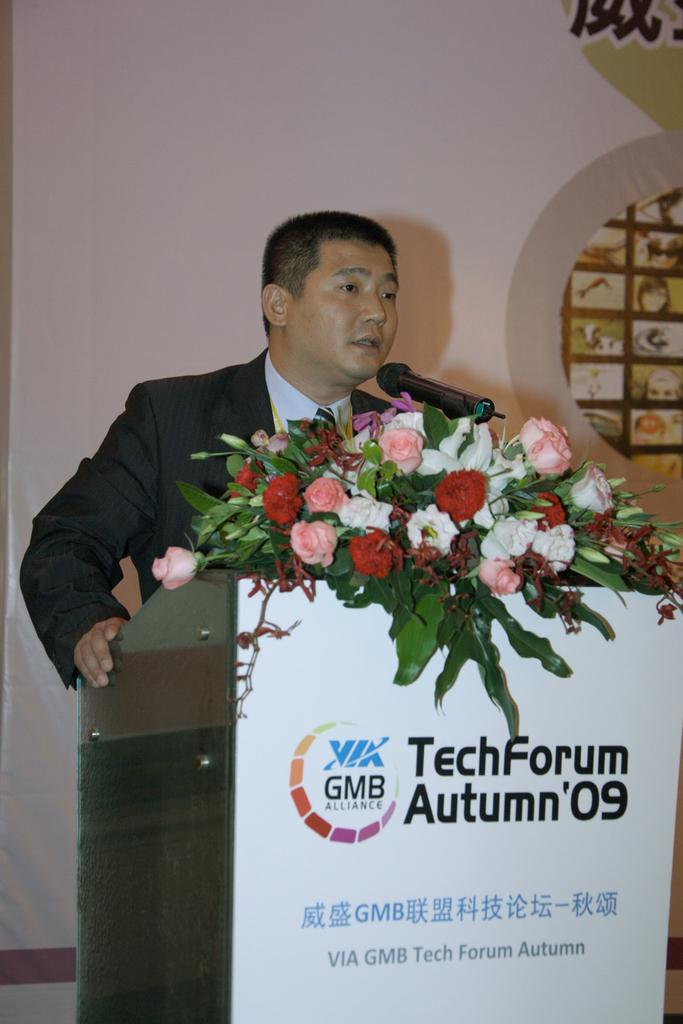What is the man in the image doing near the podium? The man is standing near a podium in the image. What is the man wearing? The man is wearing a suit. What is in front of the man on the podium? There is a microphone in front of the man. What can be seen on the microphone? There are flowers with a bokeh effect on the microphone. What is visible at the back of the scene? There is a wall at the back of the scene. What type of substance is the man using to clean the microphone in the image? There is no indication in the image that the man is using any substance to clean the microphone. 